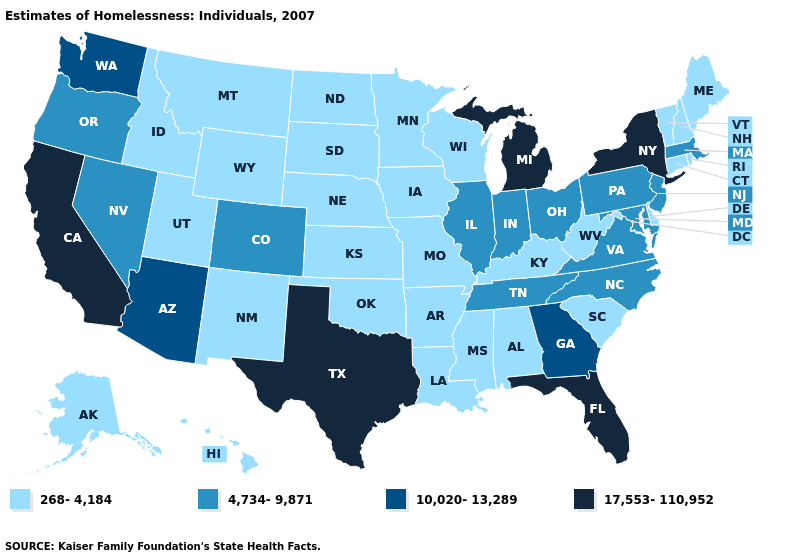Name the states that have a value in the range 268-4,184?
Short answer required. Alabama, Alaska, Arkansas, Connecticut, Delaware, Hawaii, Idaho, Iowa, Kansas, Kentucky, Louisiana, Maine, Minnesota, Mississippi, Missouri, Montana, Nebraska, New Hampshire, New Mexico, North Dakota, Oklahoma, Rhode Island, South Carolina, South Dakota, Utah, Vermont, West Virginia, Wisconsin, Wyoming. Name the states that have a value in the range 10,020-13,289?
Answer briefly. Arizona, Georgia, Washington. Name the states that have a value in the range 268-4,184?
Keep it brief. Alabama, Alaska, Arkansas, Connecticut, Delaware, Hawaii, Idaho, Iowa, Kansas, Kentucky, Louisiana, Maine, Minnesota, Mississippi, Missouri, Montana, Nebraska, New Hampshire, New Mexico, North Dakota, Oklahoma, Rhode Island, South Carolina, South Dakota, Utah, Vermont, West Virginia, Wisconsin, Wyoming. What is the value of Arizona?
Quick response, please. 10,020-13,289. What is the value of Illinois?
Be succinct. 4,734-9,871. Among the states that border West Virginia , does Virginia have the lowest value?
Keep it brief. No. What is the lowest value in states that border Kansas?
Keep it brief. 268-4,184. Does New York have the highest value in the USA?
Keep it brief. Yes. Name the states that have a value in the range 10,020-13,289?
Quick response, please. Arizona, Georgia, Washington. What is the value of North Dakota?
Write a very short answer. 268-4,184. Which states have the highest value in the USA?
Be succinct. California, Florida, Michigan, New York, Texas. Does the first symbol in the legend represent the smallest category?
Concise answer only. Yes. Name the states that have a value in the range 17,553-110,952?
Short answer required. California, Florida, Michigan, New York, Texas. What is the value of Kansas?
Short answer required. 268-4,184. 